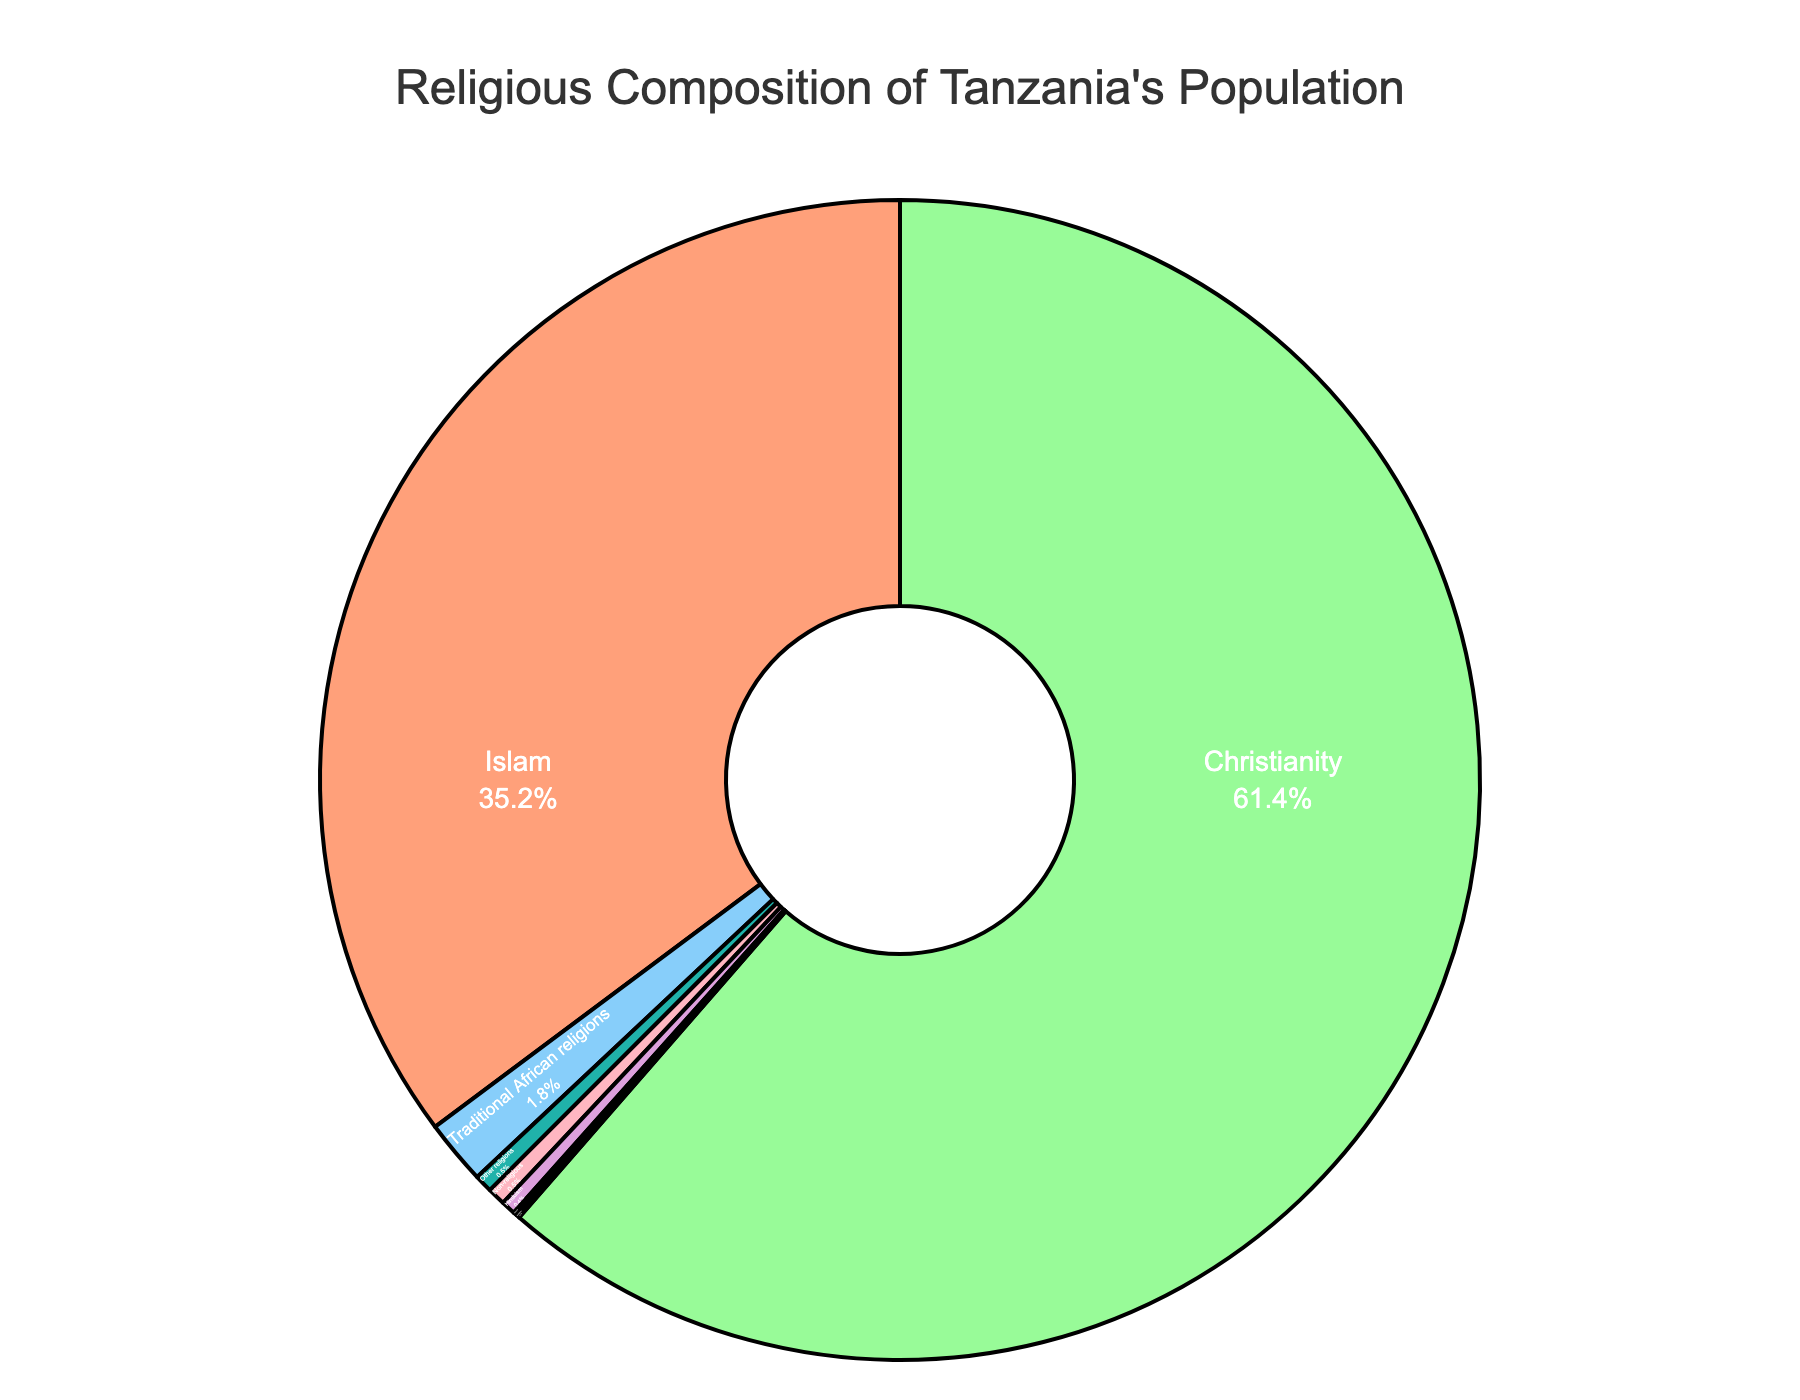what is the percentage of people following Christianity? From the pie chart, the percentage is labeled as 61.4% under Christianity.
Answer: 61.4% Which religion has the second highest percentage after Christianity? The pie chart shows Islam as the second highest with 35.2%.
Answer: Islam What is the combined percentage of people following less common religions (Hinduism, Sikhism, Buddhism, Other religions)? Add the percentages: 0.4% (Hinduism) + 0.1% (Sikhism) + 0.1% (Buddhism) + 0.5% (Other religions) = 1.1%.
Answer: 1.1% How much greater is the percentage of Christians compared to Muslims? Subtract the percentage of Islam (35.2%) from Christianity (61.4%): 61.4% - 35.2% = 26.2%.
Answer: 26.2% What is the percentage of people who are Non-religious? The pie chart shows that the percentage for Non-religious is 0.5%.
Answer: 0.5% Which religion has the smallest percentage of followers? The pie chart shows Sikhism and Buddhism each having 0.1%, which are the smallest percentages.
Answer: Sikhism and Buddhism What is the visual representation color of Islam in the pie chart? The visual color used for Islam in the pie chart is not specified in the description, but it can be identified by its percentage (35.2%).
Answer: Not specified (must refer to the visual) If you add the percentages of Christianity and Islam, what is the total? Adding the percentages of Christianity (61.4%) and Islam (35.2%) gives: 61.4% + 35.2% = 96.6%.
Answer: 96.6% Which religion has a percentage closest to 1%? Traditional African religions have a percentage of 1.8%, which is the closest to 1%.
Answer: Traditional African religions What are the visual features used to represent the religions in the pie chart? The pie chart uses different colors and text positions inside the slices, labeled with the name and percentage of each religion.
Answer: Colors and text labels 